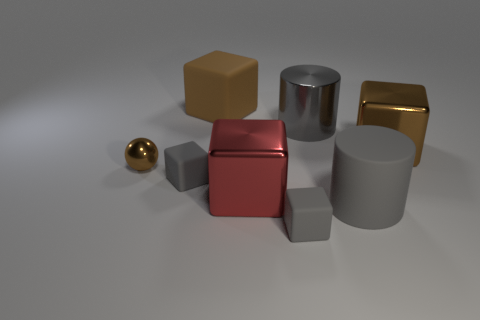Can you tell me the shapes and colors of the objects you see? Certainly! I see a collection of geometric shapes: one red cube, one gold cube, one silver cylinder, one brown cube, one small gold sphere, and three gray cubes of varying sizes. 